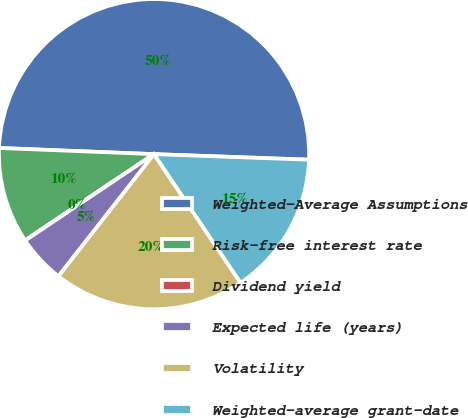Convert chart. <chart><loc_0><loc_0><loc_500><loc_500><pie_chart><fcel>Weighted-Average Assumptions<fcel>Risk-free interest rate<fcel>Dividend yield<fcel>Expected life (years)<fcel>Volatility<fcel>Weighted-average grant-date<nl><fcel>49.93%<fcel>10.01%<fcel>0.03%<fcel>5.02%<fcel>19.99%<fcel>15.0%<nl></chart> 